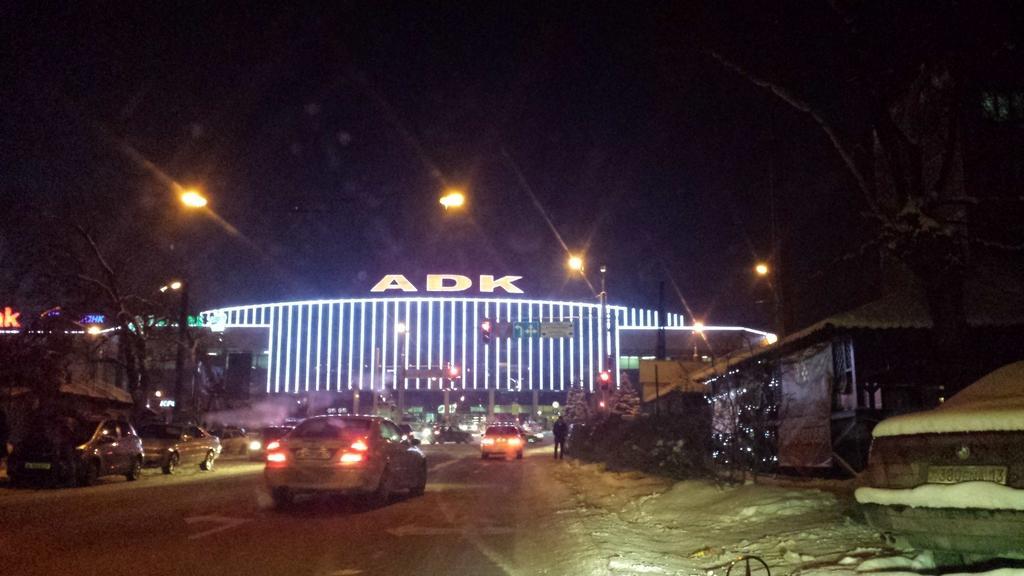In one or two sentences, can you explain what this image depicts? There is a road. On that there are many vehicles. On the sides of the road there are trees, buildings and light poles. In the background there is a building with lights and something is written on that. 